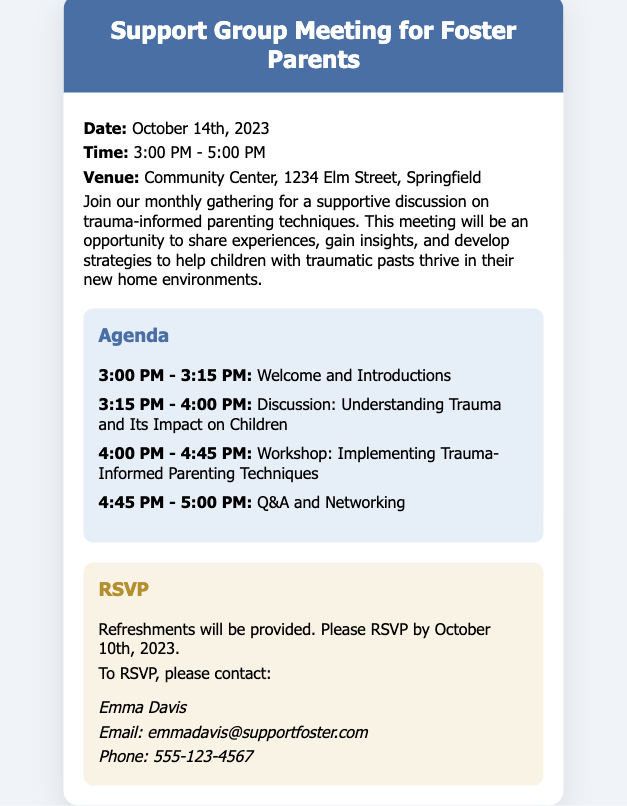What is the date of the meeting? The date is explicitly stated in the document under the event details as October 14th, 2023.
Answer: October 14th, 2023 What time does the meeting start? The start time is listed in the event details section as 3:00 PM.
Answer: 3:00 PM Who is the contact person for RSVPs? The document specifies Emma Davis as the contact person for RSVPs.
Answer: Emma Davis What is the venue for the meeting? The venue is mentioned in the event details and is located at 1234 Elm Street, Springfield.
Answer: Community Center, 1234 Elm Street, Springfield What type of parenting techniques will be discussed? The document states that the discussion will focus on trauma-informed parenting techniques.
Answer: Trauma-informed parenting techniques When is the RSVP deadline? The RSVP deadline is specified in the RSVP section as October 10th, 2023.
Answer: October 10th, 2023 How long is the meeting scheduled to last? By analyzing the start and end time, the meeting lasts from 3:00 PM to 5:00 PM for a total of 2 hours.
Answer: 2 hours What will be provided at the meeting? The document mentions that refreshments will be provided during the meeting.
Answer: Refreshments What is the agenda item that occurs last? The last agenda item listed is Q&A and Networking, occurring from 4:45 PM - 5:00 PM.
Answer: Q&A and Networking 